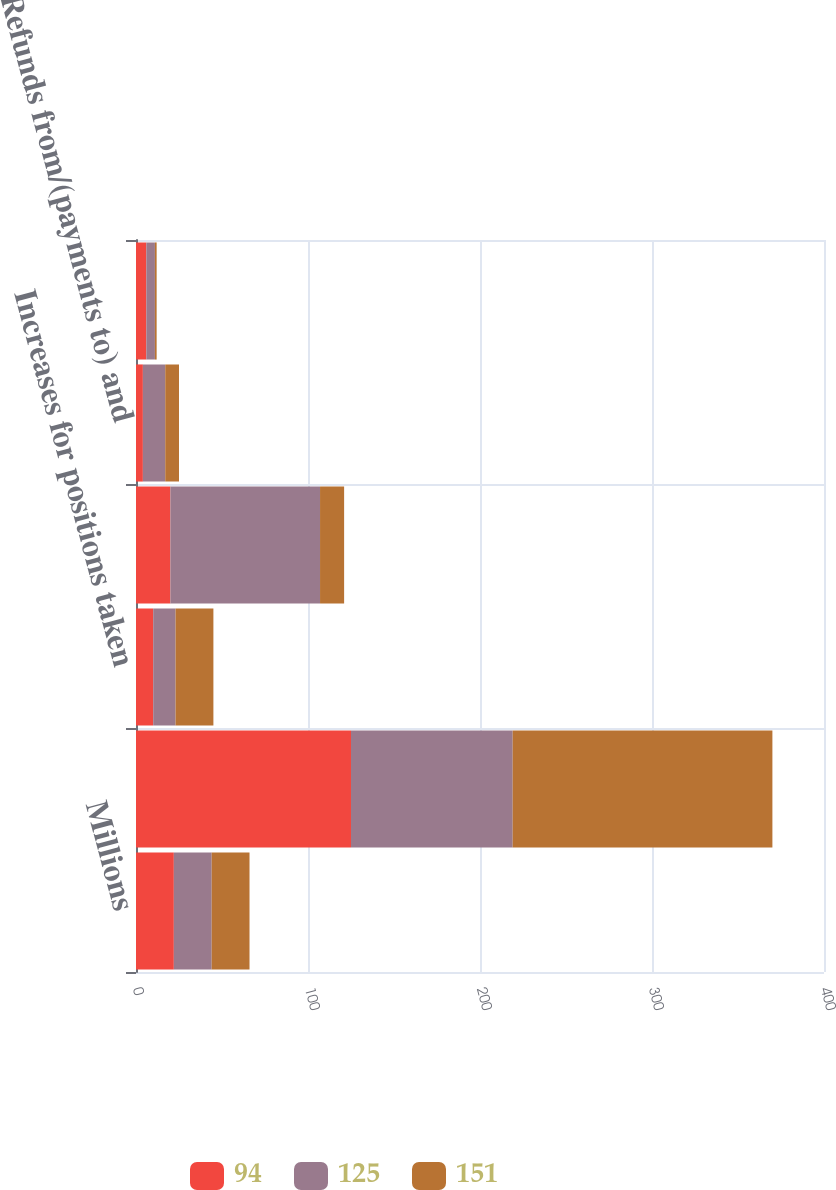Convert chart. <chart><loc_0><loc_0><loc_500><loc_500><stacked_bar_chart><ecel><fcel>Millions<fcel>Unrecognized tax benefits at<fcel>Increases for positions taken<fcel>Decreases for positions taken<fcel>Refunds from/(payments to) and<fcel>Increases/(decreases) for<nl><fcel>94<fcel>22<fcel>125<fcel>10<fcel>20<fcel>4<fcel>6<nl><fcel>125<fcel>22<fcel>94<fcel>13<fcel>87<fcel>13<fcel>5<nl><fcel>151<fcel>22<fcel>151<fcel>22<fcel>14<fcel>8<fcel>1<nl></chart> 